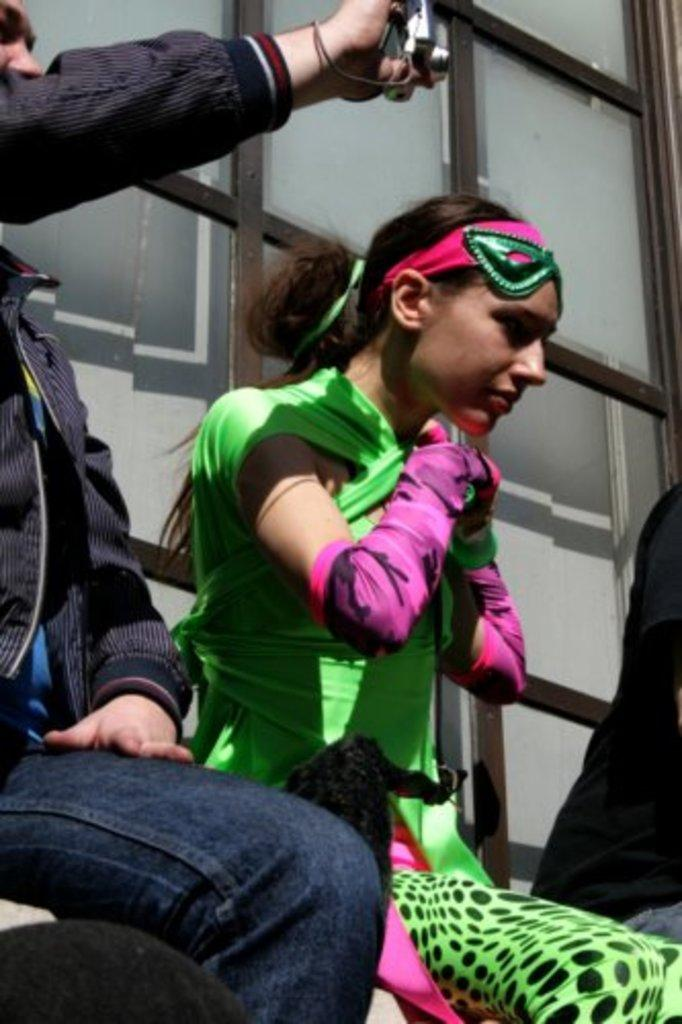What is the man on the left side of the image doing? The man is holding a camera and sitting on the left side of the image. What is the man wearing on his face? The man is wearing a mask. Who is sitting near the man? There is a lady sitting near the man. What protective gear is the lady wearing? The lady is wearing gloves and a mask. What can be seen in the background of the image? There is a wall with glass in the background of the image. What type of slope can be seen in the image? There is no slope present in the image. What activity is the man and lady participating in together? The provided facts do not specify any activity that the man and lady are participating in together. 